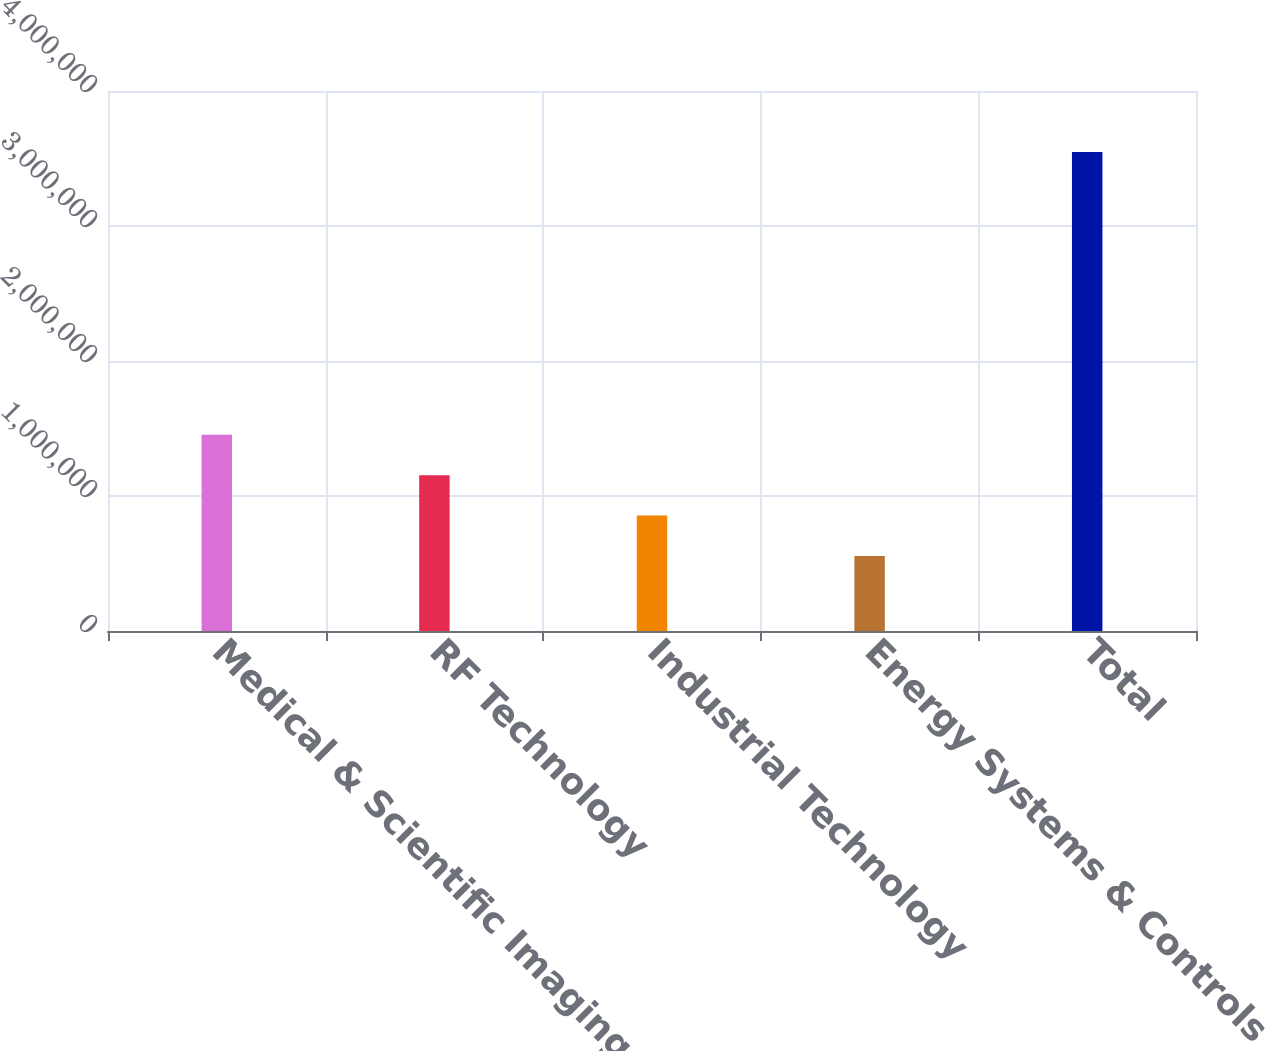<chart> <loc_0><loc_0><loc_500><loc_500><bar_chart><fcel>Medical & Scientific Imaging<fcel>RF Technology<fcel>Industrial Technology<fcel>Energy Systems & Controls<fcel>Total<nl><fcel>1.45326e+06<fcel>1.15406e+06<fcel>854867<fcel>555672<fcel>3.54762e+06<nl></chart> 